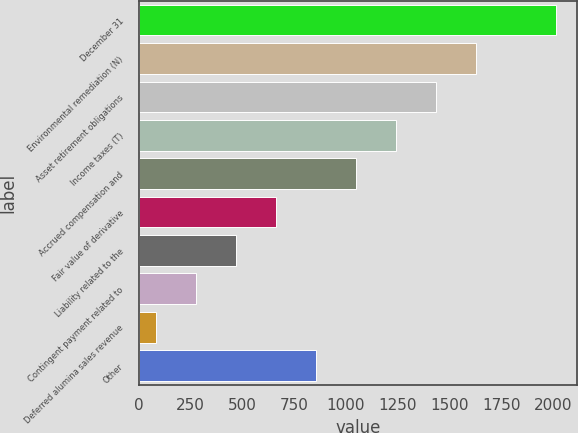<chart> <loc_0><loc_0><loc_500><loc_500><bar_chart><fcel>December 31<fcel>Environmental remediation (N)<fcel>Asset retirement obligations<fcel>Income taxes (T)<fcel>Accrued compensation and<fcel>Fair value of derivative<fcel>Liability related to the<fcel>Contingent payment related to<fcel>Deferred alumina sales revenue<fcel>Other<nl><fcel>2015<fcel>1628.8<fcel>1435.7<fcel>1242.6<fcel>1049.5<fcel>663.3<fcel>470.2<fcel>277.1<fcel>84<fcel>856.4<nl></chart> 